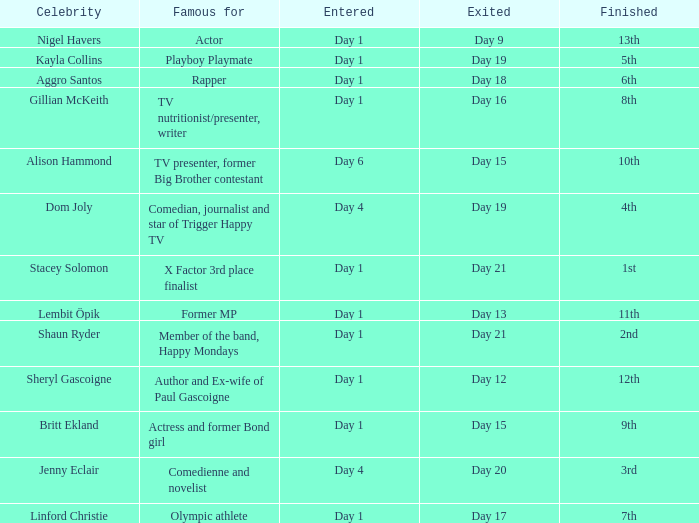What position did the celebrity finish that entered on day 1 and exited on day 15? 9th. 